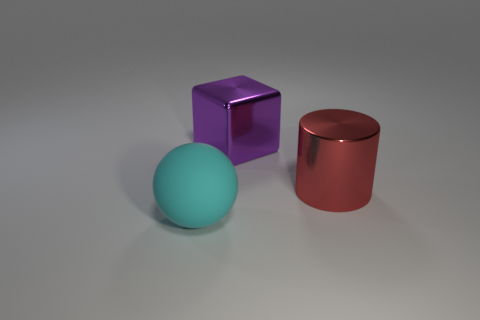Add 3 big cylinders. How many objects exist? 6 Subtract all cylinders. How many objects are left? 2 Subtract all big red metallic objects. Subtract all red things. How many objects are left? 1 Add 1 shiny cylinders. How many shiny cylinders are left? 2 Add 2 small yellow spheres. How many small yellow spheres exist? 2 Subtract 0 purple cylinders. How many objects are left? 3 